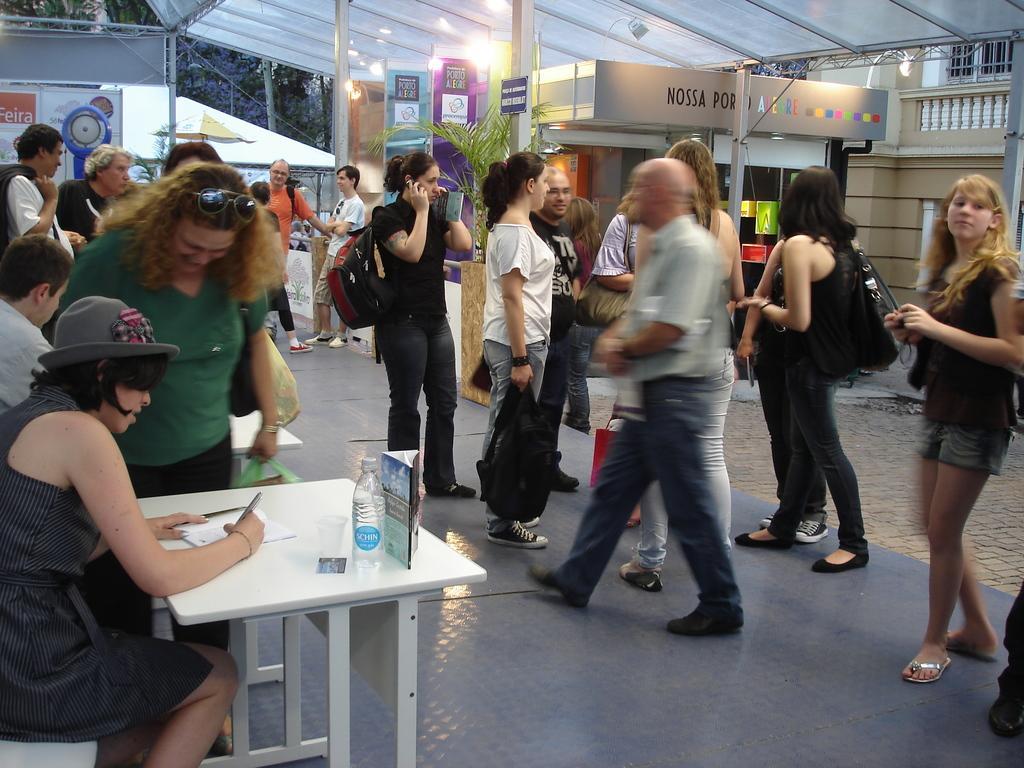How would you summarize this image in a sentence or two? There are group of people standing here and some of them are walking. There is a woman sitting on a chair in front of the table, writing something. In the background there are some lights and plants. 